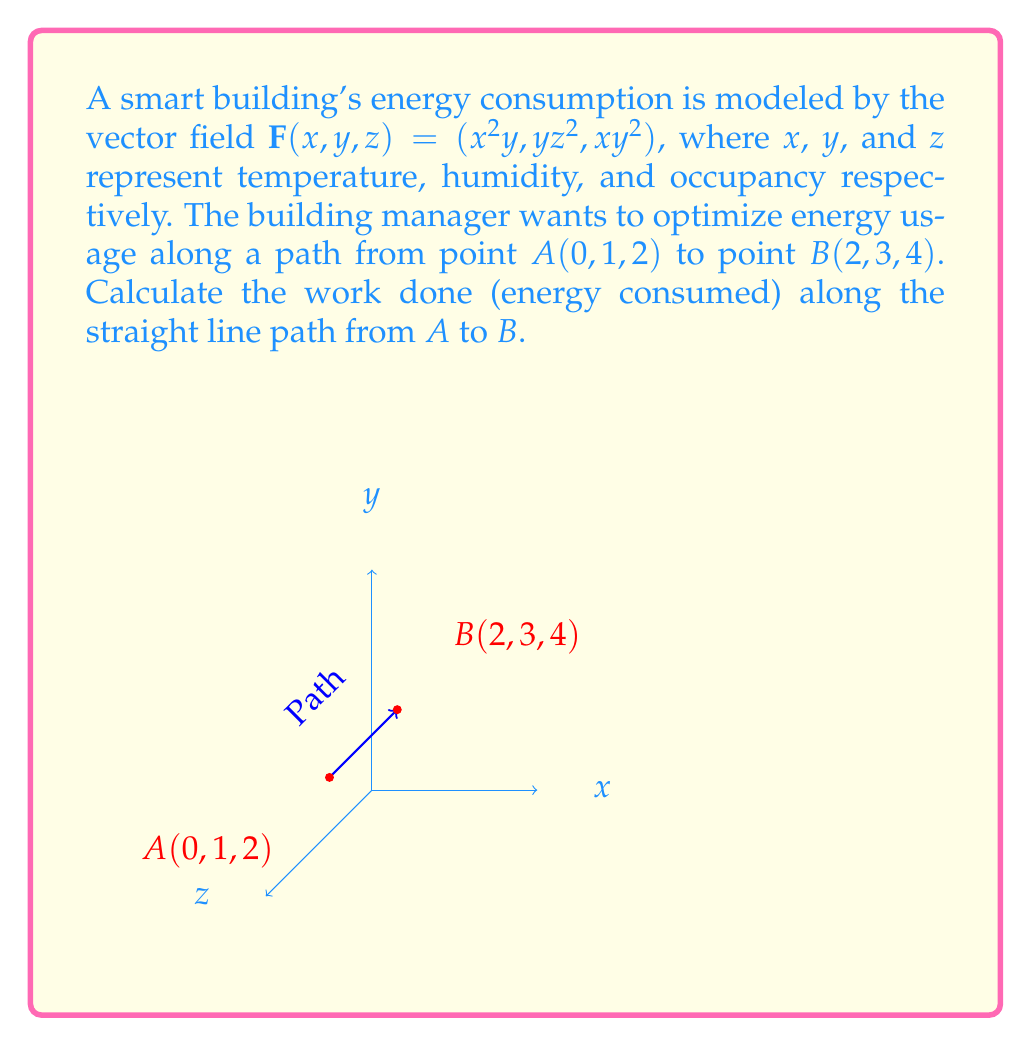Could you help me with this problem? To solve this problem, we'll use the line integral of a vector field along a curve. The steps are as follows:

1) First, we need to parameterize the straight line path from $A$ to $B$. We can do this using:

   $\mathbf{r}(t) = (1-t)A + tB$, where $0 \leq t \leq 1$

   $\mathbf{r}(t) = (1-t)(0,1,2) + t(2,3,4)$
   $\mathbf{r}(t) = (2t, 1+2t, 2+2t)$

2) Now we need to find $\frac{d\mathbf{r}}{dt}$:

   $\frac{d\mathbf{r}}{dt} = (2, 2, 2)$

3) The line integral is given by:

   $\int_C \mathbf{F} \cdot d\mathbf{r} = \int_0^1 \mathbf{F}(\mathbf{r}(t)) \cdot \frac{d\mathbf{r}}{dt} dt$

4) Let's substitute our values:

   $\int_0^1 ((2t)^2(1+2t), (1+2t)(2+2t)^2, (2t)(1+2t)^2) \cdot (2, 2, 2) dt$

5) Simplify:

   $\int_0^1 (4t^2(1+2t) + 2(1+2t)(4+8t+4t^2) + 4t(1+4t+4t^2)) dt$

6) Expand:

   $\int_0^1 (4t^2+8t^3 + 8+32t+32t^2 + 4t+16t^2+16t^3) dt$

7) Collect like terms:

   $\int_0^1 (8 + 36t + 52t^2 + 24t^3) dt$

8) Integrate:

   $[8t + 18t^2 + \frac{52}{3}t^3 + 6t^4]_0^1$

9) Evaluate the integral:

   $(8 + 18 + \frac{52}{3} + 6) - (0) = 8 + 18 + \frac{52}{3} + 6 = 32 + \frac{52}{3} = \frac{148}{3}$
Answer: $\frac{148}{3}$ energy units 